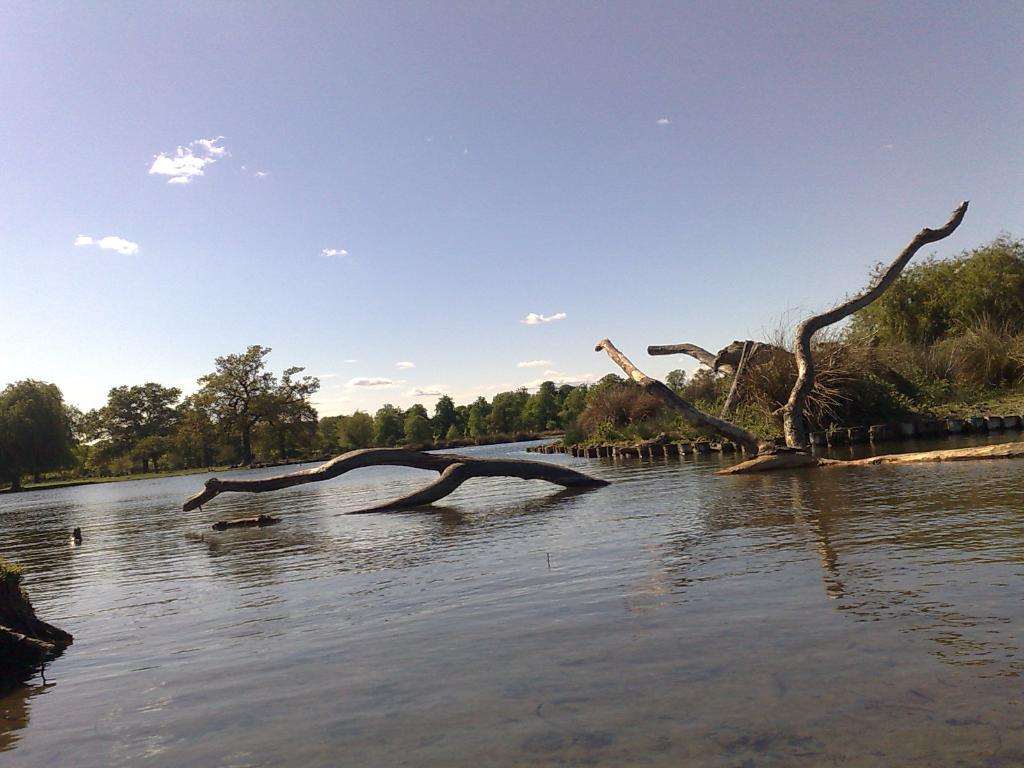What is the main subject of the image? The main subject of the image is a river. What can be seen surrounding the river in the image? The river is surrounded by trees and plants. How would you describe the sky in the image? The sky is bright in the image. What type of creature can be seen drawing with chalk on the riverbank in the image? There is no creature present in the image, and no chalk or drawing activity is depicted. How many bananas are hanging from the trees surrounding the river in the image? There are no bananas present in the image; the trees surrounding the river are not fruit-bearing trees. 